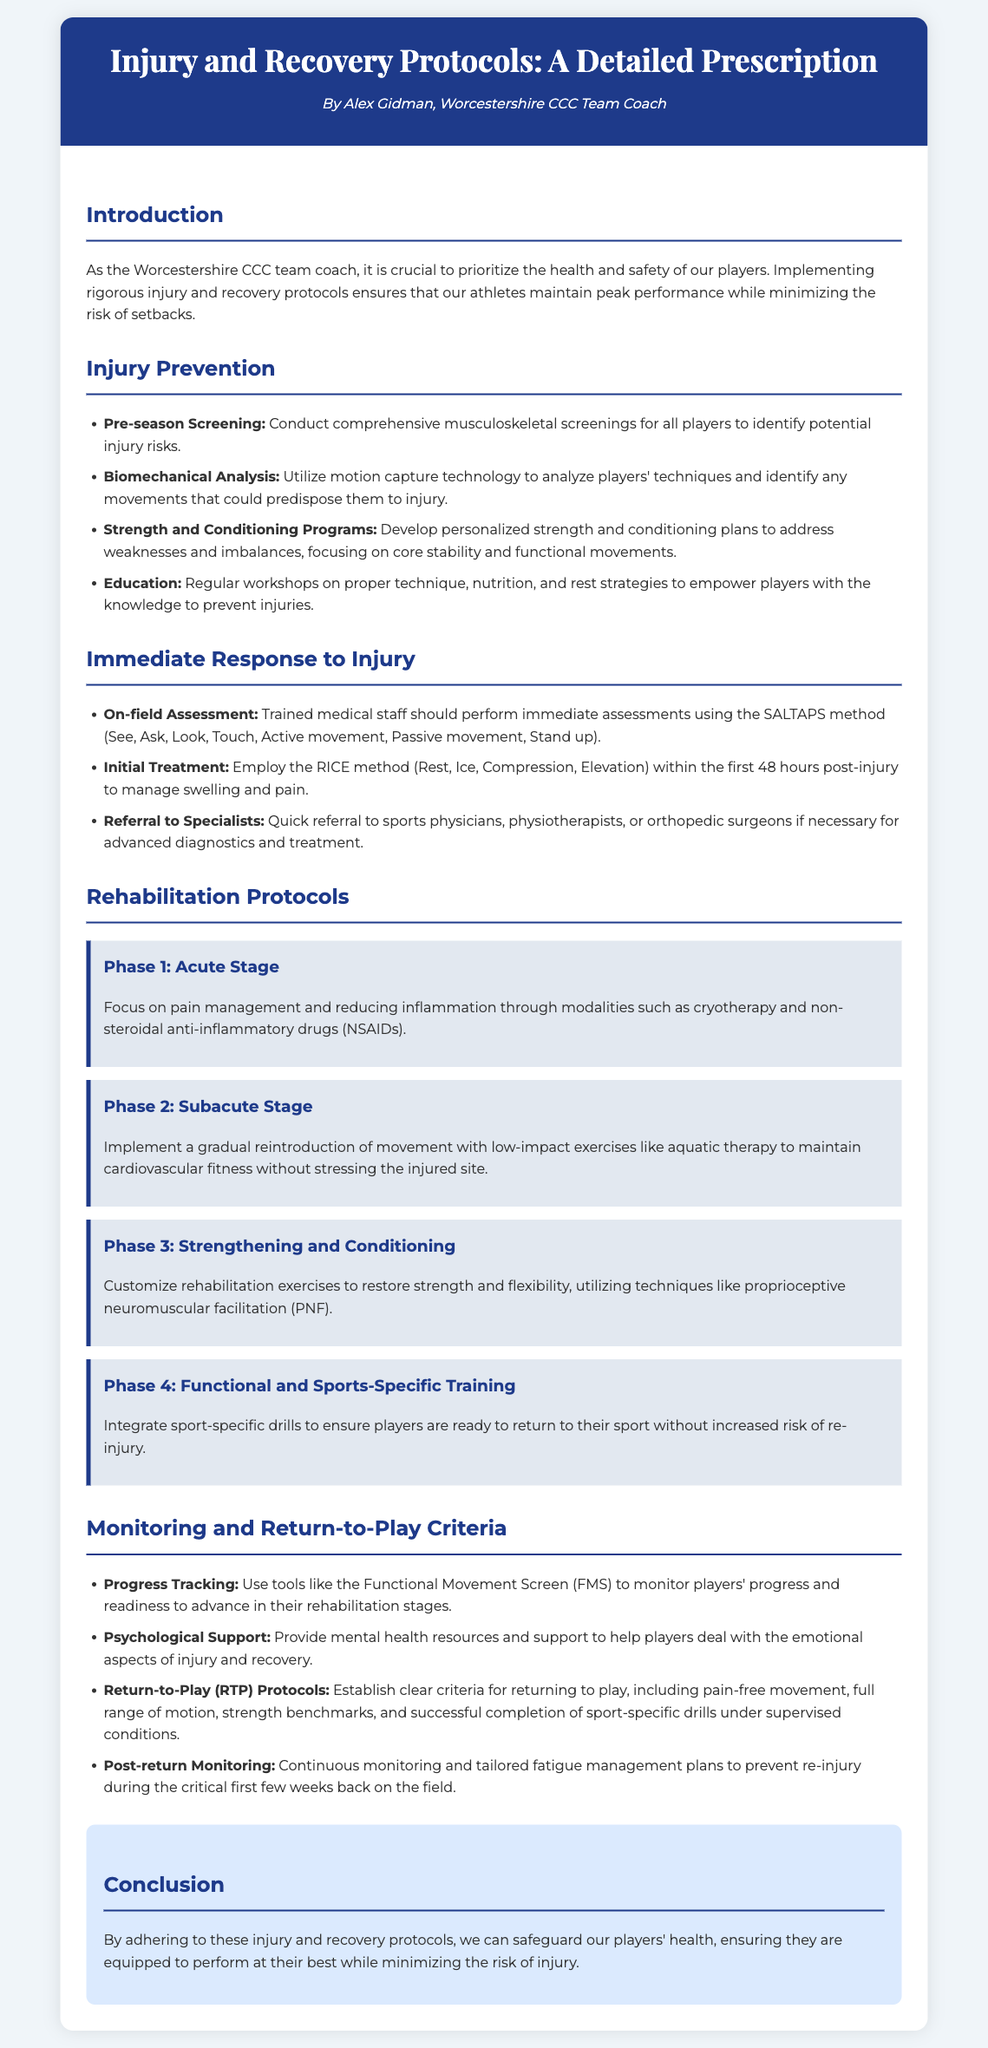What is the title of the document? The title is found in the header section of the document which outlines the main topic discussed.
Answer: Injury and Recovery Protocols: A Detailed Prescription Who authored the document? The author is mentioned in the header section which includes the name of the person who created the document.
Answer: Alex Gidman What method is used for initial treatment post-injury? The document provides specific methods for immediate treatment of injuries, identified in the relevant section.
Answer: RICE How many rehabilitation phases are outlined in the document? The document lists the phases of rehabilitation in the Rehabilitation Protocols section, which provides a clear count.
Answer: Four What tool is suggested for monitoring players' progress? In the Monitoring and Return-to-Play Criteria section, the document mentions specific assessment tools used to track rehabilitation progress.
Answer: Functional Movement Screen (FMS) What psychological support is mentioned? The document discusses mental health resources provided to players during recovery in the relevant section on monitoring.
Answer: Mental health resources What is the focus of Phase 2 in the Rehabilitation Protocols? The document outlines the focus of each rehabilitation phase, with Phase 2 dedicated to a specific type of activity.
Answer: Gradual reintroduction of movement Which educational aspect is emphasized for injury prevention? The Injury Prevention section highlights various educational strategies aimed at empowering players to avoid injuries.
Answer: Workshops on proper technique, nutrition, and rest strategies What is the primary objective of the protocols outlined in the conclusion? The conclusion summarizes the main goal of the protocols discussed throughout the document, providing a clear objective.
Answer: Safeguard players’ health 